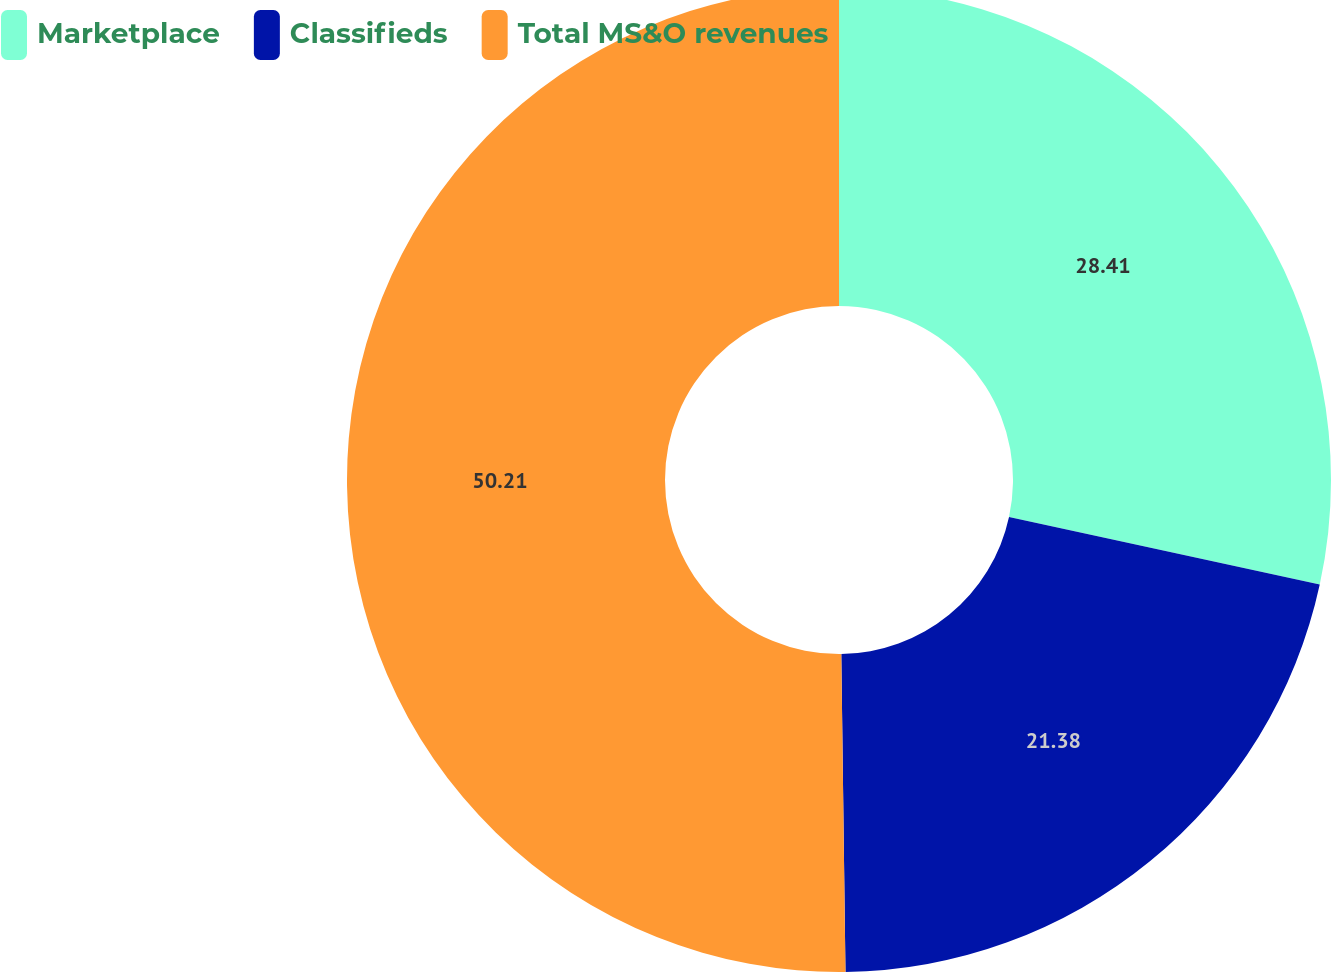Convert chart. <chart><loc_0><loc_0><loc_500><loc_500><pie_chart><fcel>Marketplace<fcel>Classifieds<fcel>Total MS&O revenues<nl><fcel>28.41%<fcel>21.38%<fcel>50.21%<nl></chart> 